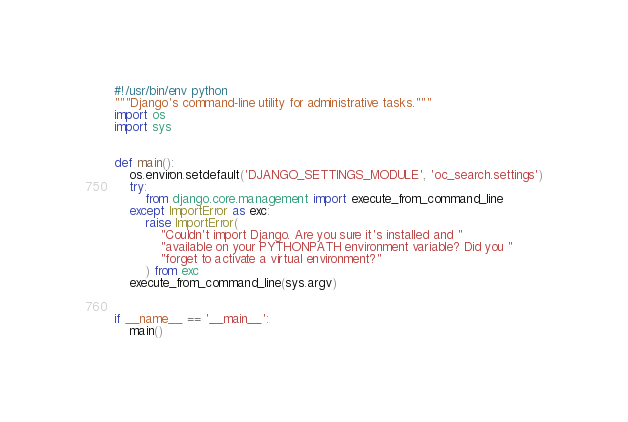<code> <loc_0><loc_0><loc_500><loc_500><_Python_>#!/usr/bin/env python
"""Django's command-line utility for administrative tasks."""
import os
import sys


def main():
    os.environ.setdefault('DJANGO_SETTINGS_MODULE', 'oc_search.settings')
    try:
        from django.core.management import execute_from_command_line
    except ImportError as exc:
        raise ImportError(
            "Couldn't import Django. Are you sure it's installed and "
            "available on your PYTHONPATH environment variable? Did you "
            "forget to activate a virtual environment?"
        ) from exc
    execute_from_command_line(sys.argv)


if __name__ == '__main__':
    main()
</code> 